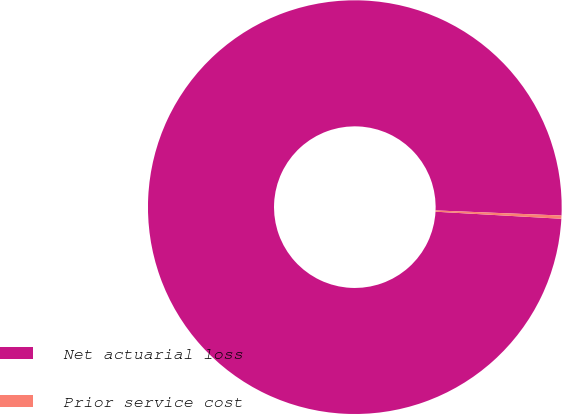Convert chart to OTSL. <chart><loc_0><loc_0><loc_500><loc_500><pie_chart><fcel>Net actuarial loss<fcel>Prior service cost<nl><fcel>99.75%<fcel>0.25%<nl></chart> 